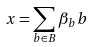<formula> <loc_0><loc_0><loc_500><loc_500>x = \sum _ { b \in B } \beta _ { b } b</formula> 